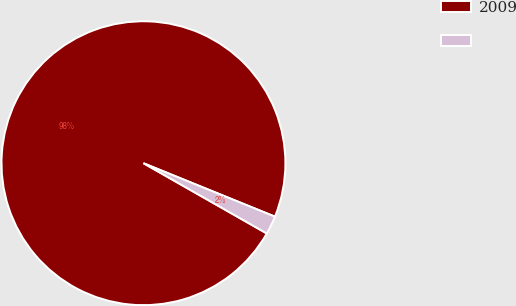Convert chart to OTSL. <chart><loc_0><loc_0><loc_500><loc_500><pie_chart><fcel>2009<fcel>Unnamed: 1<nl><fcel>97.9%<fcel>2.1%<nl></chart> 